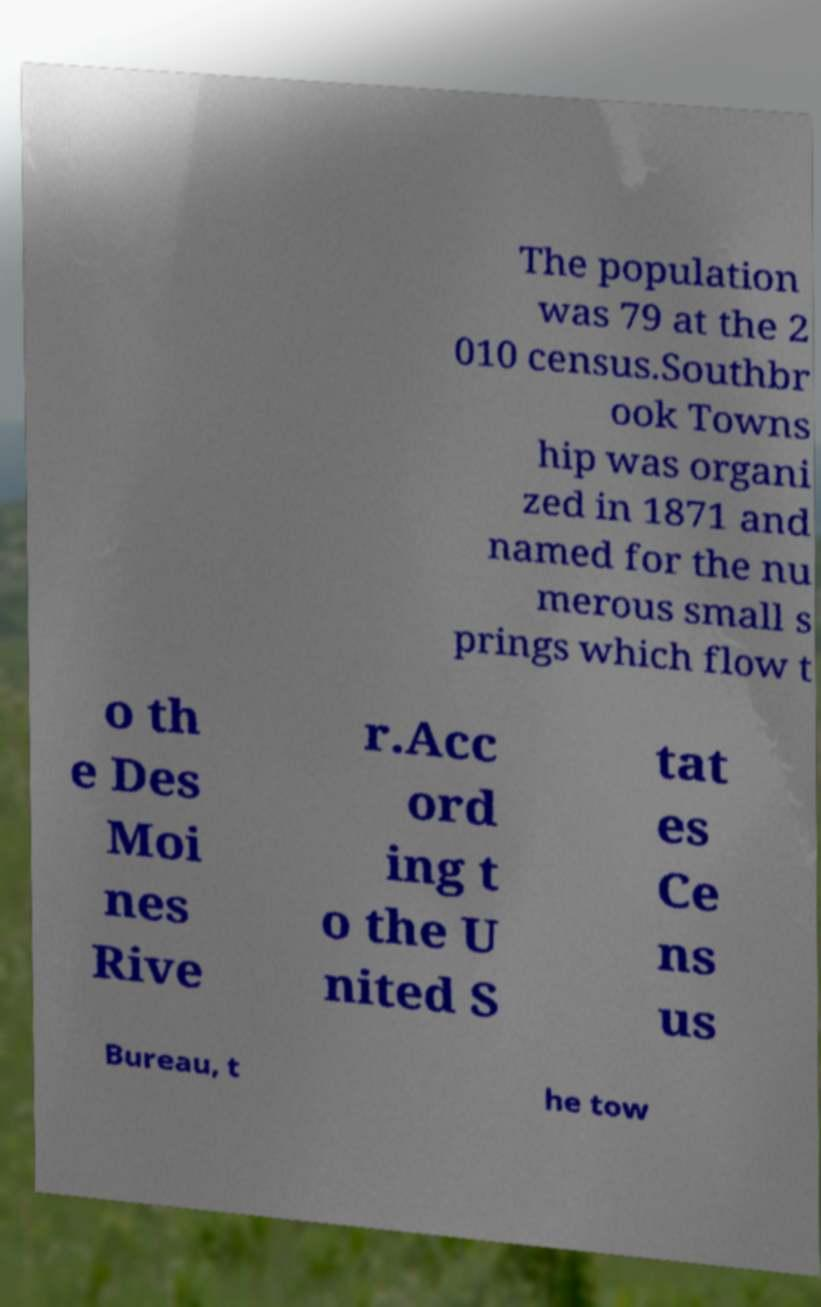I need the written content from this picture converted into text. Can you do that? The population was 79 at the 2 010 census.Southbr ook Towns hip was organi zed in 1871 and named for the nu merous small s prings which flow t o th e Des Moi nes Rive r.Acc ord ing t o the U nited S tat es Ce ns us Bureau, t he tow 